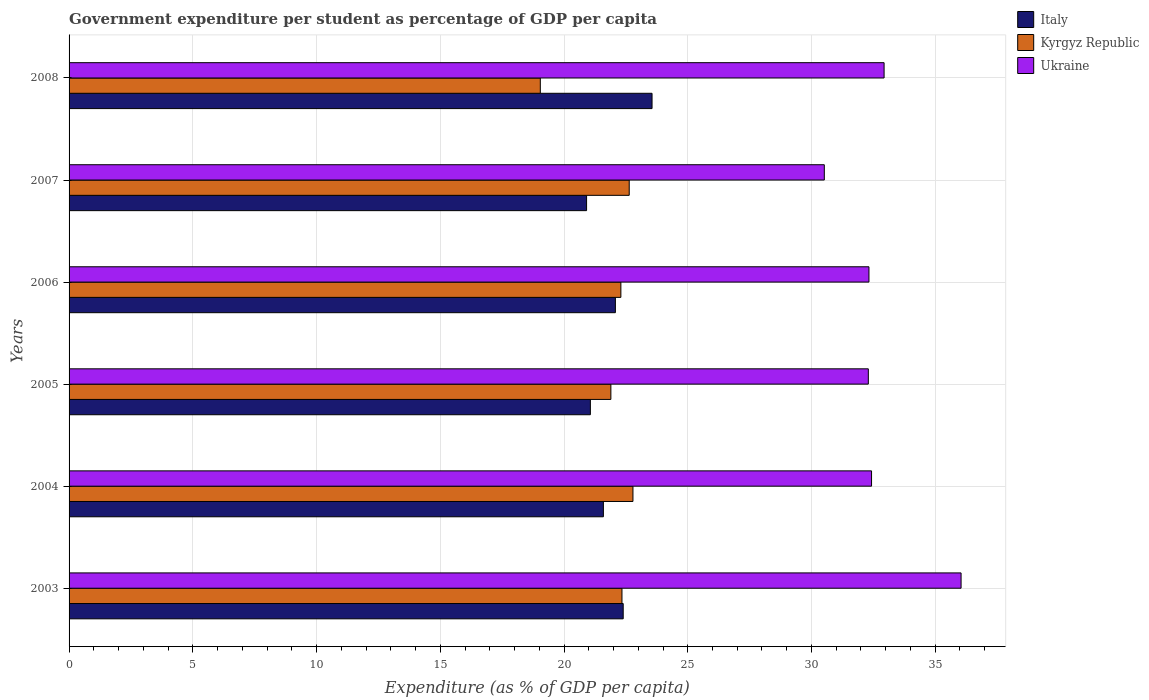Are the number of bars per tick equal to the number of legend labels?
Offer a very short reply. Yes. How many bars are there on the 6th tick from the bottom?
Ensure brevity in your answer.  3. What is the percentage of expenditure per student in Kyrgyz Republic in 2006?
Provide a succinct answer. 22.3. Across all years, what is the maximum percentage of expenditure per student in Ukraine?
Ensure brevity in your answer.  36.05. Across all years, what is the minimum percentage of expenditure per student in Ukraine?
Ensure brevity in your answer.  30.52. In which year was the percentage of expenditure per student in Ukraine maximum?
Keep it short and to the point. 2003. What is the total percentage of expenditure per student in Kyrgyz Republic in the graph?
Your answer should be very brief. 131. What is the difference between the percentage of expenditure per student in Kyrgyz Republic in 2007 and that in 2008?
Provide a succinct answer. 3.59. What is the difference between the percentage of expenditure per student in Kyrgyz Republic in 2005 and the percentage of expenditure per student in Italy in 2003?
Provide a short and direct response. -0.5. What is the average percentage of expenditure per student in Kyrgyz Republic per year?
Offer a terse response. 21.83. In the year 2005, what is the difference between the percentage of expenditure per student in Ukraine and percentage of expenditure per student in Italy?
Your answer should be very brief. 11.23. In how many years, is the percentage of expenditure per student in Ukraine greater than 17 %?
Make the answer very short. 6. What is the ratio of the percentage of expenditure per student in Kyrgyz Republic in 2006 to that in 2008?
Your answer should be compact. 1.17. Is the percentage of expenditure per student in Italy in 2004 less than that in 2005?
Your answer should be compact. No. What is the difference between the highest and the second highest percentage of expenditure per student in Ukraine?
Provide a short and direct response. 3.11. What is the difference between the highest and the lowest percentage of expenditure per student in Italy?
Offer a terse response. 2.65. In how many years, is the percentage of expenditure per student in Ukraine greater than the average percentage of expenditure per student in Ukraine taken over all years?
Offer a terse response. 2. Is the sum of the percentage of expenditure per student in Ukraine in 2005 and 2008 greater than the maximum percentage of expenditure per student in Italy across all years?
Ensure brevity in your answer.  Yes. What does the 2nd bar from the top in 2005 represents?
Ensure brevity in your answer.  Kyrgyz Republic. How many bars are there?
Give a very brief answer. 18. Are all the bars in the graph horizontal?
Keep it short and to the point. Yes. How many years are there in the graph?
Make the answer very short. 6. Are the values on the major ticks of X-axis written in scientific E-notation?
Provide a succinct answer. No. Does the graph contain grids?
Give a very brief answer. Yes. Where does the legend appear in the graph?
Give a very brief answer. Top right. How many legend labels are there?
Your answer should be compact. 3. How are the legend labels stacked?
Offer a very short reply. Vertical. What is the title of the graph?
Provide a short and direct response. Government expenditure per student as percentage of GDP per capita. What is the label or title of the X-axis?
Your answer should be very brief. Expenditure (as % of GDP per capita). What is the Expenditure (as % of GDP per capita) of Italy in 2003?
Offer a terse response. 22.39. What is the Expenditure (as % of GDP per capita) in Kyrgyz Republic in 2003?
Provide a short and direct response. 22.34. What is the Expenditure (as % of GDP per capita) of Ukraine in 2003?
Keep it short and to the point. 36.05. What is the Expenditure (as % of GDP per capita) in Italy in 2004?
Provide a short and direct response. 21.59. What is the Expenditure (as % of GDP per capita) of Kyrgyz Republic in 2004?
Ensure brevity in your answer.  22.79. What is the Expenditure (as % of GDP per capita) in Ukraine in 2004?
Your answer should be very brief. 32.43. What is the Expenditure (as % of GDP per capita) in Italy in 2005?
Keep it short and to the point. 21.07. What is the Expenditure (as % of GDP per capita) in Kyrgyz Republic in 2005?
Your answer should be compact. 21.89. What is the Expenditure (as % of GDP per capita) in Ukraine in 2005?
Offer a terse response. 32.3. What is the Expenditure (as % of GDP per capita) in Italy in 2006?
Ensure brevity in your answer.  22.08. What is the Expenditure (as % of GDP per capita) in Kyrgyz Republic in 2006?
Your answer should be compact. 22.3. What is the Expenditure (as % of GDP per capita) of Ukraine in 2006?
Your answer should be very brief. 32.32. What is the Expenditure (as % of GDP per capita) of Italy in 2007?
Your response must be concise. 20.91. What is the Expenditure (as % of GDP per capita) in Kyrgyz Republic in 2007?
Make the answer very short. 22.64. What is the Expenditure (as % of GDP per capita) of Ukraine in 2007?
Keep it short and to the point. 30.52. What is the Expenditure (as % of GDP per capita) of Italy in 2008?
Your answer should be very brief. 23.56. What is the Expenditure (as % of GDP per capita) of Kyrgyz Republic in 2008?
Ensure brevity in your answer.  19.04. What is the Expenditure (as % of GDP per capita) in Ukraine in 2008?
Give a very brief answer. 32.93. Across all years, what is the maximum Expenditure (as % of GDP per capita) in Italy?
Provide a short and direct response. 23.56. Across all years, what is the maximum Expenditure (as % of GDP per capita) of Kyrgyz Republic?
Ensure brevity in your answer.  22.79. Across all years, what is the maximum Expenditure (as % of GDP per capita) in Ukraine?
Provide a short and direct response. 36.05. Across all years, what is the minimum Expenditure (as % of GDP per capita) in Italy?
Provide a succinct answer. 20.91. Across all years, what is the minimum Expenditure (as % of GDP per capita) of Kyrgyz Republic?
Make the answer very short. 19.04. Across all years, what is the minimum Expenditure (as % of GDP per capita) of Ukraine?
Offer a terse response. 30.52. What is the total Expenditure (as % of GDP per capita) of Italy in the graph?
Your response must be concise. 131.59. What is the total Expenditure (as % of GDP per capita) in Kyrgyz Republic in the graph?
Make the answer very short. 131. What is the total Expenditure (as % of GDP per capita) of Ukraine in the graph?
Provide a short and direct response. 196.54. What is the difference between the Expenditure (as % of GDP per capita) in Italy in 2003 and that in 2004?
Provide a short and direct response. 0.8. What is the difference between the Expenditure (as % of GDP per capita) in Kyrgyz Republic in 2003 and that in 2004?
Ensure brevity in your answer.  -0.44. What is the difference between the Expenditure (as % of GDP per capita) in Ukraine in 2003 and that in 2004?
Keep it short and to the point. 3.62. What is the difference between the Expenditure (as % of GDP per capita) in Italy in 2003 and that in 2005?
Provide a short and direct response. 1.33. What is the difference between the Expenditure (as % of GDP per capita) in Kyrgyz Republic in 2003 and that in 2005?
Give a very brief answer. 0.45. What is the difference between the Expenditure (as % of GDP per capita) of Ukraine in 2003 and that in 2005?
Your response must be concise. 3.75. What is the difference between the Expenditure (as % of GDP per capita) of Italy in 2003 and that in 2006?
Your answer should be very brief. 0.32. What is the difference between the Expenditure (as % of GDP per capita) in Kyrgyz Republic in 2003 and that in 2006?
Offer a very short reply. 0.04. What is the difference between the Expenditure (as % of GDP per capita) in Ukraine in 2003 and that in 2006?
Your answer should be very brief. 3.72. What is the difference between the Expenditure (as % of GDP per capita) in Italy in 2003 and that in 2007?
Ensure brevity in your answer.  1.48. What is the difference between the Expenditure (as % of GDP per capita) of Kyrgyz Republic in 2003 and that in 2007?
Provide a short and direct response. -0.29. What is the difference between the Expenditure (as % of GDP per capita) of Ukraine in 2003 and that in 2007?
Provide a succinct answer. 5.53. What is the difference between the Expenditure (as % of GDP per capita) in Italy in 2003 and that in 2008?
Offer a very short reply. -1.17. What is the difference between the Expenditure (as % of GDP per capita) of Kyrgyz Republic in 2003 and that in 2008?
Ensure brevity in your answer.  3.3. What is the difference between the Expenditure (as % of GDP per capita) of Ukraine in 2003 and that in 2008?
Your response must be concise. 3.11. What is the difference between the Expenditure (as % of GDP per capita) in Italy in 2004 and that in 2005?
Offer a very short reply. 0.53. What is the difference between the Expenditure (as % of GDP per capita) of Kyrgyz Republic in 2004 and that in 2005?
Keep it short and to the point. 0.89. What is the difference between the Expenditure (as % of GDP per capita) of Ukraine in 2004 and that in 2005?
Ensure brevity in your answer.  0.13. What is the difference between the Expenditure (as % of GDP per capita) of Italy in 2004 and that in 2006?
Give a very brief answer. -0.49. What is the difference between the Expenditure (as % of GDP per capita) in Kyrgyz Republic in 2004 and that in 2006?
Provide a short and direct response. 0.49. What is the difference between the Expenditure (as % of GDP per capita) of Ukraine in 2004 and that in 2006?
Your answer should be compact. 0.11. What is the difference between the Expenditure (as % of GDP per capita) of Italy in 2004 and that in 2007?
Ensure brevity in your answer.  0.68. What is the difference between the Expenditure (as % of GDP per capita) of Kyrgyz Republic in 2004 and that in 2007?
Make the answer very short. 0.15. What is the difference between the Expenditure (as % of GDP per capita) in Ukraine in 2004 and that in 2007?
Ensure brevity in your answer.  1.91. What is the difference between the Expenditure (as % of GDP per capita) of Italy in 2004 and that in 2008?
Your answer should be very brief. -1.97. What is the difference between the Expenditure (as % of GDP per capita) of Kyrgyz Republic in 2004 and that in 2008?
Your response must be concise. 3.74. What is the difference between the Expenditure (as % of GDP per capita) of Ukraine in 2004 and that in 2008?
Your answer should be compact. -0.51. What is the difference between the Expenditure (as % of GDP per capita) of Italy in 2005 and that in 2006?
Your answer should be compact. -1.01. What is the difference between the Expenditure (as % of GDP per capita) of Kyrgyz Republic in 2005 and that in 2006?
Offer a very short reply. -0.4. What is the difference between the Expenditure (as % of GDP per capita) in Ukraine in 2005 and that in 2006?
Your answer should be compact. -0.03. What is the difference between the Expenditure (as % of GDP per capita) of Italy in 2005 and that in 2007?
Offer a terse response. 0.15. What is the difference between the Expenditure (as % of GDP per capita) of Kyrgyz Republic in 2005 and that in 2007?
Provide a short and direct response. -0.74. What is the difference between the Expenditure (as % of GDP per capita) in Ukraine in 2005 and that in 2007?
Your answer should be very brief. 1.78. What is the difference between the Expenditure (as % of GDP per capita) in Italy in 2005 and that in 2008?
Keep it short and to the point. -2.49. What is the difference between the Expenditure (as % of GDP per capita) of Kyrgyz Republic in 2005 and that in 2008?
Keep it short and to the point. 2.85. What is the difference between the Expenditure (as % of GDP per capita) in Ukraine in 2005 and that in 2008?
Provide a short and direct response. -0.64. What is the difference between the Expenditure (as % of GDP per capita) in Italy in 2006 and that in 2007?
Offer a very short reply. 1.16. What is the difference between the Expenditure (as % of GDP per capita) of Kyrgyz Republic in 2006 and that in 2007?
Make the answer very short. -0.34. What is the difference between the Expenditure (as % of GDP per capita) in Ukraine in 2006 and that in 2007?
Your answer should be compact. 1.8. What is the difference between the Expenditure (as % of GDP per capita) of Italy in 2006 and that in 2008?
Provide a succinct answer. -1.48. What is the difference between the Expenditure (as % of GDP per capita) of Kyrgyz Republic in 2006 and that in 2008?
Ensure brevity in your answer.  3.26. What is the difference between the Expenditure (as % of GDP per capita) of Ukraine in 2006 and that in 2008?
Keep it short and to the point. -0.61. What is the difference between the Expenditure (as % of GDP per capita) in Italy in 2007 and that in 2008?
Offer a terse response. -2.65. What is the difference between the Expenditure (as % of GDP per capita) of Kyrgyz Republic in 2007 and that in 2008?
Keep it short and to the point. 3.59. What is the difference between the Expenditure (as % of GDP per capita) in Ukraine in 2007 and that in 2008?
Provide a short and direct response. -2.42. What is the difference between the Expenditure (as % of GDP per capita) of Italy in 2003 and the Expenditure (as % of GDP per capita) of Kyrgyz Republic in 2004?
Provide a succinct answer. -0.39. What is the difference between the Expenditure (as % of GDP per capita) in Italy in 2003 and the Expenditure (as % of GDP per capita) in Ukraine in 2004?
Ensure brevity in your answer.  -10.04. What is the difference between the Expenditure (as % of GDP per capita) of Kyrgyz Republic in 2003 and the Expenditure (as % of GDP per capita) of Ukraine in 2004?
Keep it short and to the point. -10.09. What is the difference between the Expenditure (as % of GDP per capita) in Italy in 2003 and the Expenditure (as % of GDP per capita) in Kyrgyz Republic in 2005?
Your response must be concise. 0.5. What is the difference between the Expenditure (as % of GDP per capita) of Italy in 2003 and the Expenditure (as % of GDP per capita) of Ukraine in 2005?
Provide a short and direct response. -9.91. What is the difference between the Expenditure (as % of GDP per capita) of Kyrgyz Republic in 2003 and the Expenditure (as % of GDP per capita) of Ukraine in 2005?
Your answer should be very brief. -9.96. What is the difference between the Expenditure (as % of GDP per capita) of Italy in 2003 and the Expenditure (as % of GDP per capita) of Kyrgyz Republic in 2006?
Ensure brevity in your answer.  0.09. What is the difference between the Expenditure (as % of GDP per capita) of Italy in 2003 and the Expenditure (as % of GDP per capita) of Ukraine in 2006?
Keep it short and to the point. -9.93. What is the difference between the Expenditure (as % of GDP per capita) in Kyrgyz Republic in 2003 and the Expenditure (as % of GDP per capita) in Ukraine in 2006?
Make the answer very short. -9.98. What is the difference between the Expenditure (as % of GDP per capita) of Italy in 2003 and the Expenditure (as % of GDP per capita) of Kyrgyz Republic in 2007?
Give a very brief answer. -0.24. What is the difference between the Expenditure (as % of GDP per capita) of Italy in 2003 and the Expenditure (as % of GDP per capita) of Ukraine in 2007?
Provide a short and direct response. -8.13. What is the difference between the Expenditure (as % of GDP per capita) in Kyrgyz Republic in 2003 and the Expenditure (as % of GDP per capita) in Ukraine in 2007?
Your answer should be very brief. -8.18. What is the difference between the Expenditure (as % of GDP per capita) of Italy in 2003 and the Expenditure (as % of GDP per capita) of Kyrgyz Republic in 2008?
Make the answer very short. 3.35. What is the difference between the Expenditure (as % of GDP per capita) in Italy in 2003 and the Expenditure (as % of GDP per capita) in Ukraine in 2008?
Make the answer very short. -10.54. What is the difference between the Expenditure (as % of GDP per capita) of Kyrgyz Republic in 2003 and the Expenditure (as % of GDP per capita) of Ukraine in 2008?
Offer a terse response. -10.59. What is the difference between the Expenditure (as % of GDP per capita) in Italy in 2004 and the Expenditure (as % of GDP per capita) in Kyrgyz Republic in 2005?
Give a very brief answer. -0.3. What is the difference between the Expenditure (as % of GDP per capita) of Italy in 2004 and the Expenditure (as % of GDP per capita) of Ukraine in 2005?
Give a very brief answer. -10.71. What is the difference between the Expenditure (as % of GDP per capita) of Kyrgyz Republic in 2004 and the Expenditure (as % of GDP per capita) of Ukraine in 2005?
Keep it short and to the point. -9.51. What is the difference between the Expenditure (as % of GDP per capita) in Italy in 2004 and the Expenditure (as % of GDP per capita) in Kyrgyz Republic in 2006?
Offer a terse response. -0.71. What is the difference between the Expenditure (as % of GDP per capita) in Italy in 2004 and the Expenditure (as % of GDP per capita) in Ukraine in 2006?
Make the answer very short. -10.73. What is the difference between the Expenditure (as % of GDP per capita) in Kyrgyz Republic in 2004 and the Expenditure (as % of GDP per capita) in Ukraine in 2006?
Provide a short and direct response. -9.54. What is the difference between the Expenditure (as % of GDP per capita) of Italy in 2004 and the Expenditure (as % of GDP per capita) of Kyrgyz Republic in 2007?
Ensure brevity in your answer.  -1.04. What is the difference between the Expenditure (as % of GDP per capita) in Italy in 2004 and the Expenditure (as % of GDP per capita) in Ukraine in 2007?
Give a very brief answer. -8.93. What is the difference between the Expenditure (as % of GDP per capita) in Kyrgyz Republic in 2004 and the Expenditure (as % of GDP per capita) in Ukraine in 2007?
Provide a short and direct response. -7.73. What is the difference between the Expenditure (as % of GDP per capita) in Italy in 2004 and the Expenditure (as % of GDP per capita) in Kyrgyz Republic in 2008?
Ensure brevity in your answer.  2.55. What is the difference between the Expenditure (as % of GDP per capita) in Italy in 2004 and the Expenditure (as % of GDP per capita) in Ukraine in 2008?
Provide a short and direct response. -11.34. What is the difference between the Expenditure (as % of GDP per capita) of Kyrgyz Republic in 2004 and the Expenditure (as % of GDP per capita) of Ukraine in 2008?
Your response must be concise. -10.15. What is the difference between the Expenditure (as % of GDP per capita) of Italy in 2005 and the Expenditure (as % of GDP per capita) of Kyrgyz Republic in 2006?
Ensure brevity in your answer.  -1.23. What is the difference between the Expenditure (as % of GDP per capita) of Italy in 2005 and the Expenditure (as % of GDP per capita) of Ukraine in 2006?
Your response must be concise. -11.26. What is the difference between the Expenditure (as % of GDP per capita) of Kyrgyz Republic in 2005 and the Expenditure (as % of GDP per capita) of Ukraine in 2006?
Your answer should be very brief. -10.43. What is the difference between the Expenditure (as % of GDP per capita) in Italy in 2005 and the Expenditure (as % of GDP per capita) in Kyrgyz Republic in 2007?
Give a very brief answer. -1.57. What is the difference between the Expenditure (as % of GDP per capita) of Italy in 2005 and the Expenditure (as % of GDP per capita) of Ukraine in 2007?
Keep it short and to the point. -9.45. What is the difference between the Expenditure (as % of GDP per capita) in Kyrgyz Republic in 2005 and the Expenditure (as % of GDP per capita) in Ukraine in 2007?
Your answer should be compact. -8.62. What is the difference between the Expenditure (as % of GDP per capita) in Italy in 2005 and the Expenditure (as % of GDP per capita) in Kyrgyz Republic in 2008?
Ensure brevity in your answer.  2.02. What is the difference between the Expenditure (as % of GDP per capita) in Italy in 2005 and the Expenditure (as % of GDP per capita) in Ukraine in 2008?
Give a very brief answer. -11.87. What is the difference between the Expenditure (as % of GDP per capita) in Kyrgyz Republic in 2005 and the Expenditure (as % of GDP per capita) in Ukraine in 2008?
Keep it short and to the point. -11.04. What is the difference between the Expenditure (as % of GDP per capita) in Italy in 2006 and the Expenditure (as % of GDP per capita) in Kyrgyz Republic in 2007?
Your answer should be compact. -0.56. What is the difference between the Expenditure (as % of GDP per capita) of Italy in 2006 and the Expenditure (as % of GDP per capita) of Ukraine in 2007?
Your answer should be very brief. -8.44. What is the difference between the Expenditure (as % of GDP per capita) of Kyrgyz Republic in 2006 and the Expenditure (as % of GDP per capita) of Ukraine in 2007?
Make the answer very short. -8.22. What is the difference between the Expenditure (as % of GDP per capita) of Italy in 2006 and the Expenditure (as % of GDP per capita) of Kyrgyz Republic in 2008?
Offer a terse response. 3.03. What is the difference between the Expenditure (as % of GDP per capita) in Italy in 2006 and the Expenditure (as % of GDP per capita) in Ukraine in 2008?
Offer a very short reply. -10.86. What is the difference between the Expenditure (as % of GDP per capita) of Kyrgyz Republic in 2006 and the Expenditure (as % of GDP per capita) of Ukraine in 2008?
Your answer should be compact. -10.64. What is the difference between the Expenditure (as % of GDP per capita) in Italy in 2007 and the Expenditure (as % of GDP per capita) in Kyrgyz Republic in 2008?
Ensure brevity in your answer.  1.87. What is the difference between the Expenditure (as % of GDP per capita) of Italy in 2007 and the Expenditure (as % of GDP per capita) of Ukraine in 2008?
Make the answer very short. -12.02. What is the difference between the Expenditure (as % of GDP per capita) in Kyrgyz Republic in 2007 and the Expenditure (as % of GDP per capita) in Ukraine in 2008?
Your answer should be very brief. -10.3. What is the average Expenditure (as % of GDP per capita) of Italy per year?
Offer a terse response. 21.93. What is the average Expenditure (as % of GDP per capita) of Kyrgyz Republic per year?
Ensure brevity in your answer.  21.83. What is the average Expenditure (as % of GDP per capita) in Ukraine per year?
Your answer should be compact. 32.76. In the year 2003, what is the difference between the Expenditure (as % of GDP per capita) in Italy and Expenditure (as % of GDP per capita) in Kyrgyz Republic?
Your response must be concise. 0.05. In the year 2003, what is the difference between the Expenditure (as % of GDP per capita) in Italy and Expenditure (as % of GDP per capita) in Ukraine?
Provide a succinct answer. -13.65. In the year 2003, what is the difference between the Expenditure (as % of GDP per capita) of Kyrgyz Republic and Expenditure (as % of GDP per capita) of Ukraine?
Give a very brief answer. -13.7. In the year 2004, what is the difference between the Expenditure (as % of GDP per capita) in Italy and Expenditure (as % of GDP per capita) in Kyrgyz Republic?
Your response must be concise. -1.19. In the year 2004, what is the difference between the Expenditure (as % of GDP per capita) in Italy and Expenditure (as % of GDP per capita) in Ukraine?
Provide a short and direct response. -10.84. In the year 2004, what is the difference between the Expenditure (as % of GDP per capita) in Kyrgyz Republic and Expenditure (as % of GDP per capita) in Ukraine?
Keep it short and to the point. -9.64. In the year 2005, what is the difference between the Expenditure (as % of GDP per capita) in Italy and Expenditure (as % of GDP per capita) in Kyrgyz Republic?
Make the answer very short. -0.83. In the year 2005, what is the difference between the Expenditure (as % of GDP per capita) of Italy and Expenditure (as % of GDP per capita) of Ukraine?
Offer a very short reply. -11.23. In the year 2005, what is the difference between the Expenditure (as % of GDP per capita) in Kyrgyz Republic and Expenditure (as % of GDP per capita) in Ukraine?
Offer a terse response. -10.4. In the year 2006, what is the difference between the Expenditure (as % of GDP per capita) of Italy and Expenditure (as % of GDP per capita) of Kyrgyz Republic?
Provide a short and direct response. -0.22. In the year 2006, what is the difference between the Expenditure (as % of GDP per capita) of Italy and Expenditure (as % of GDP per capita) of Ukraine?
Your answer should be compact. -10.25. In the year 2006, what is the difference between the Expenditure (as % of GDP per capita) in Kyrgyz Republic and Expenditure (as % of GDP per capita) in Ukraine?
Provide a succinct answer. -10.02. In the year 2007, what is the difference between the Expenditure (as % of GDP per capita) of Italy and Expenditure (as % of GDP per capita) of Kyrgyz Republic?
Offer a terse response. -1.72. In the year 2007, what is the difference between the Expenditure (as % of GDP per capita) in Italy and Expenditure (as % of GDP per capita) in Ukraine?
Ensure brevity in your answer.  -9.61. In the year 2007, what is the difference between the Expenditure (as % of GDP per capita) of Kyrgyz Republic and Expenditure (as % of GDP per capita) of Ukraine?
Your response must be concise. -7.88. In the year 2008, what is the difference between the Expenditure (as % of GDP per capita) of Italy and Expenditure (as % of GDP per capita) of Kyrgyz Republic?
Offer a terse response. 4.51. In the year 2008, what is the difference between the Expenditure (as % of GDP per capita) of Italy and Expenditure (as % of GDP per capita) of Ukraine?
Offer a terse response. -9.38. In the year 2008, what is the difference between the Expenditure (as % of GDP per capita) in Kyrgyz Republic and Expenditure (as % of GDP per capita) in Ukraine?
Your answer should be very brief. -13.89. What is the ratio of the Expenditure (as % of GDP per capita) of Italy in 2003 to that in 2004?
Give a very brief answer. 1.04. What is the ratio of the Expenditure (as % of GDP per capita) of Kyrgyz Republic in 2003 to that in 2004?
Your answer should be very brief. 0.98. What is the ratio of the Expenditure (as % of GDP per capita) of Ukraine in 2003 to that in 2004?
Your response must be concise. 1.11. What is the ratio of the Expenditure (as % of GDP per capita) of Italy in 2003 to that in 2005?
Offer a very short reply. 1.06. What is the ratio of the Expenditure (as % of GDP per capita) in Kyrgyz Republic in 2003 to that in 2005?
Your answer should be very brief. 1.02. What is the ratio of the Expenditure (as % of GDP per capita) in Ukraine in 2003 to that in 2005?
Make the answer very short. 1.12. What is the ratio of the Expenditure (as % of GDP per capita) in Italy in 2003 to that in 2006?
Offer a terse response. 1.01. What is the ratio of the Expenditure (as % of GDP per capita) in Ukraine in 2003 to that in 2006?
Ensure brevity in your answer.  1.12. What is the ratio of the Expenditure (as % of GDP per capita) in Italy in 2003 to that in 2007?
Provide a succinct answer. 1.07. What is the ratio of the Expenditure (as % of GDP per capita) in Ukraine in 2003 to that in 2007?
Provide a short and direct response. 1.18. What is the ratio of the Expenditure (as % of GDP per capita) in Italy in 2003 to that in 2008?
Ensure brevity in your answer.  0.95. What is the ratio of the Expenditure (as % of GDP per capita) in Kyrgyz Republic in 2003 to that in 2008?
Offer a very short reply. 1.17. What is the ratio of the Expenditure (as % of GDP per capita) of Ukraine in 2003 to that in 2008?
Ensure brevity in your answer.  1.09. What is the ratio of the Expenditure (as % of GDP per capita) in Italy in 2004 to that in 2005?
Ensure brevity in your answer.  1.02. What is the ratio of the Expenditure (as % of GDP per capita) of Kyrgyz Republic in 2004 to that in 2005?
Your response must be concise. 1.04. What is the ratio of the Expenditure (as % of GDP per capita) of Italy in 2004 to that in 2006?
Provide a short and direct response. 0.98. What is the ratio of the Expenditure (as % of GDP per capita) of Kyrgyz Republic in 2004 to that in 2006?
Your answer should be compact. 1.02. What is the ratio of the Expenditure (as % of GDP per capita) of Italy in 2004 to that in 2007?
Keep it short and to the point. 1.03. What is the ratio of the Expenditure (as % of GDP per capita) of Kyrgyz Republic in 2004 to that in 2007?
Your answer should be compact. 1.01. What is the ratio of the Expenditure (as % of GDP per capita) of Ukraine in 2004 to that in 2007?
Provide a succinct answer. 1.06. What is the ratio of the Expenditure (as % of GDP per capita) of Italy in 2004 to that in 2008?
Offer a very short reply. 0.92. What is the ratio of the Expenditure (as % of GDP per capita) in Kyrgyz Republic in 2004 to that in 2008?
Your response must be concise. 1.2. What is the ratio of the Expenditure (as % of GDP per capita) of Ukraine in 2004 to that in 2008?
Your answer should be compact. 0.98. What is the ratio of the Expenditure (as % of GDP per capita) in Italy in 2005 to that in 2006?
Offer a terse response. 0.95. What is the ratio of the Expenditure (as % of GDP per capita) of Kyrgyz Republic in 2005 to that in 2006?
Make the answer very short. 0.98. What is the ratio of the Expenditure (as % of GDP per capita) in Ukraine in 2005 to that in 2006?
Offer a terse response. 1. What is the ratio of the Expenditure (as % of GDP per capita) in Italy in 2005 to that in 2007?
Your answer should be very brief. 1.01. What is the ratio of the Expenditure (as % of GDP per capita) in Kyrgyz Republic in 2005 to that in 2007?
Give a very brief answer. 0.97. What is the ratio of the Expenditure (as % of GDP per capita) in Ukraine in 2005 to that in 2007?
Provide a short and direct response. 1.06. What is the ratio of the Expenditure (as % of GDP per capita) in Italy in 2005 to that in 2008?
Ensure brevity in your answer.  0.89. What is the ratio of the Expenditure (as % of GDP per capita) in Kyrgyz Republic in 2005 to that in 2008?
Your response must be concise. 1.15. What is the ratio of the Expenditure (as % of GDP per capita) in Ukraine in 2005 to that in 2008?
Make the answer very short. 0.98. What is the ratio of the Expenditure (as % of GDP per capita) in Italy in 2006 to that in 2007?
Your answer should be very brief. 1.06. What is the ratio of the Expenditure (as % of GDP per capita) in Kyrgyz Republic in 2006 to that in 2007?
Provide a succinct answer. 0.99. What is the ratio of the Expenditure (as % of GDP per capita) in Ukraine in 2006 to that in 2007?
Keep it short and to the point. 1.06. What is the ratio of the Expenditure (as % of GDP per capita) in Italy in 2006 to that in 2008?
Keep it short and to the point. 0.94. What is the ratio of the Expenditure (as % of GDP per capita) in Kyrgyz Republic in 2006 to that in 2008?
Keep it short and to the point. 1.17. What is the ratio of the Expenditure (as % of GDP per capita) in Ukraine in 2006 to that in 2008?
Your response must be concise. 0.98. What is the ratio of the Expenditure (as % of GDP per capita) in Italy in 2007 to that in 2008?
Ensure brevity in your answer.  0.89. What is the ratio of the Expenditure (as % of GDP per capita) in Kyrgyz Republic in 2007 to that in 2008?
Your answer should be compact. 1.19. What is the ratio of the Expenditure (as % of GDP per capita) of Ukraine in 2007 to that in 2008?
Your response must be concise. 0.93. What is the difference between the highest and the second highest Expenditure (as % of GDP per capita) of Italy?
Offer a terse response. 1.17. What is the difference between the highest and the second highest Expenditure (as % of GDP per capita) in Kyrgyz Republic?
Your answer should be very brief. 0.15. What is the difference between the highest and the second highest Expenditure (as % of GDP per capita) in Ukraine?
Give a very brief answer. 3.11. What is the difference between the highest and the lowest Expenditure (as % of GDP per capita) in Italy?
Keep it short and to the point. 2.65. What is the difference between the highest and the lowest Expenditure (as % of GDP per capita) of Kyrgyz Republic?
Give a very brief answer. 3.74. What is the difference between the highest and the lowest Expenditure (as % of GDP per capita) in Ukraine?
Your response must be concise. 5.53. 